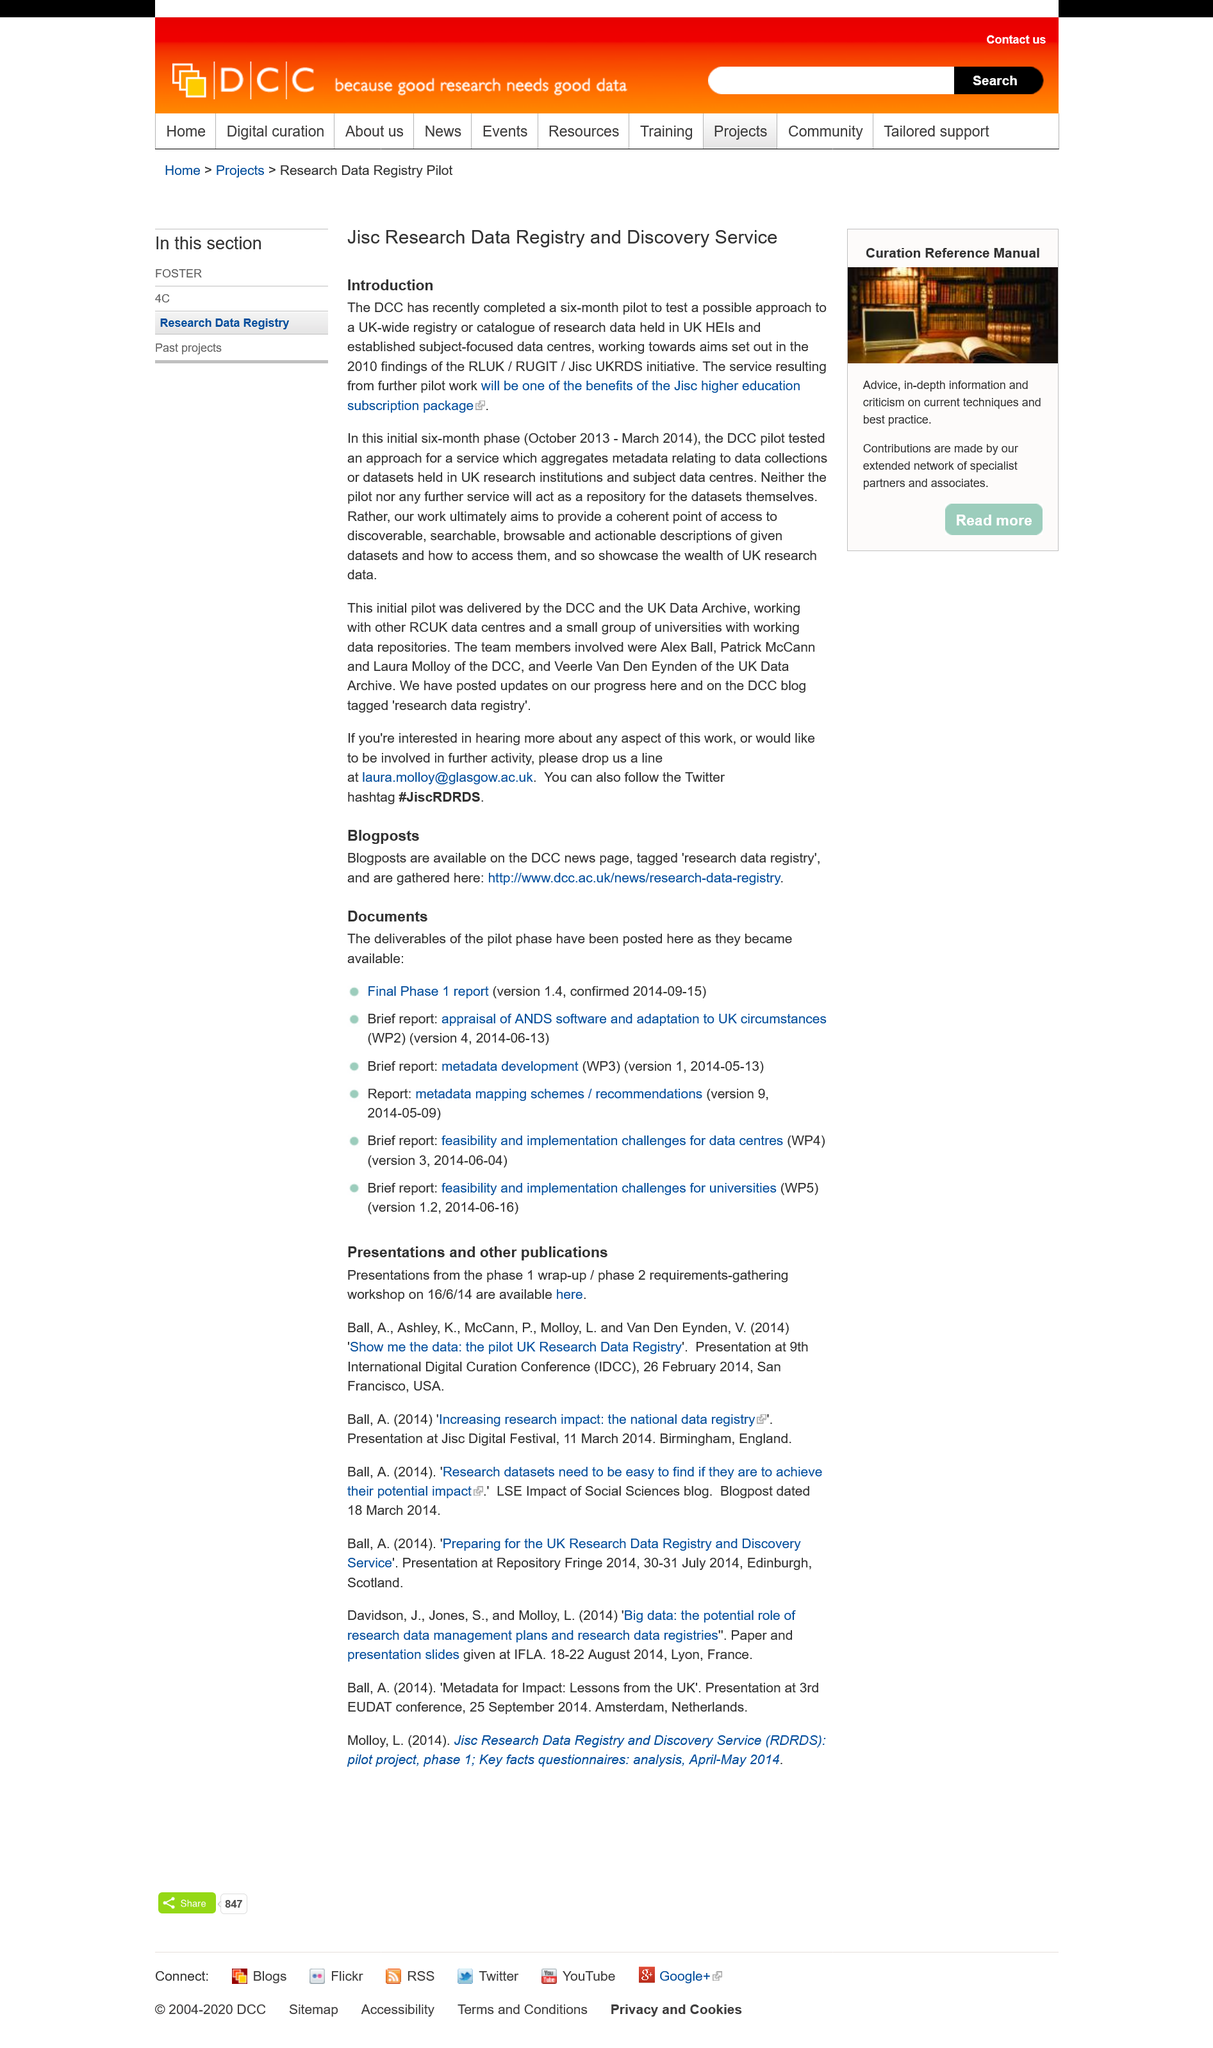Identify some key points in this picture. The Jisc Research Data Registry and Discovery Service is a registry and service that is called Jisc Research Data Registry and Discovery Service. The Jisc higher education subscription package will provide customers with access to a service that will be a significant benefit. The DCC's six-month pilot testing was completed on March 2014. 